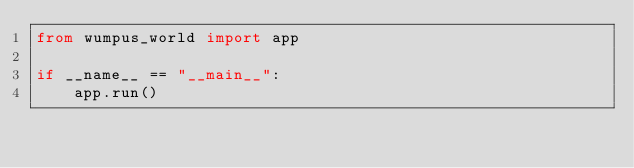Convert code to text. <code><loc_0><loc_0><loc_500><loc_500><_Python_>from wumpus_world import app

if __name__ == "__main__":
    app.run()
</code> 